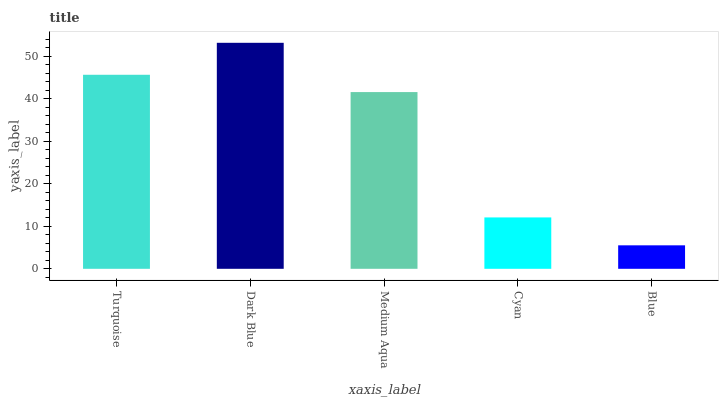Is Blue the minimum?
Answer yes or no. Yes. Is Dark Blue the maximum?
Answer yes or no. Yes. Is Medium Aqua the minimum?
Answer yes or no. No. Is Medium Aqua the maximum?
Answer yes or no. No. Is Dark Blue greater than Medium Aqua?
Answer yes or no. Yes. Is Medium Aqua less than Dark Blue?
Answer yes or no. Yes. Is Medium Aqua greater than Dark Blue?
Answer yes or no. No. Is Dark Blue less than Medium Aqua?
Answer yes or no. No. Is Medium Aqua the high median?
Answer yes or no. Yes. Is Medium Aqua the low median?
Answer yes or no. Yes. Is Blue the high median?
Answer yes or no. No. Is Dark Blue the low median?
Answer yes or no. No. 